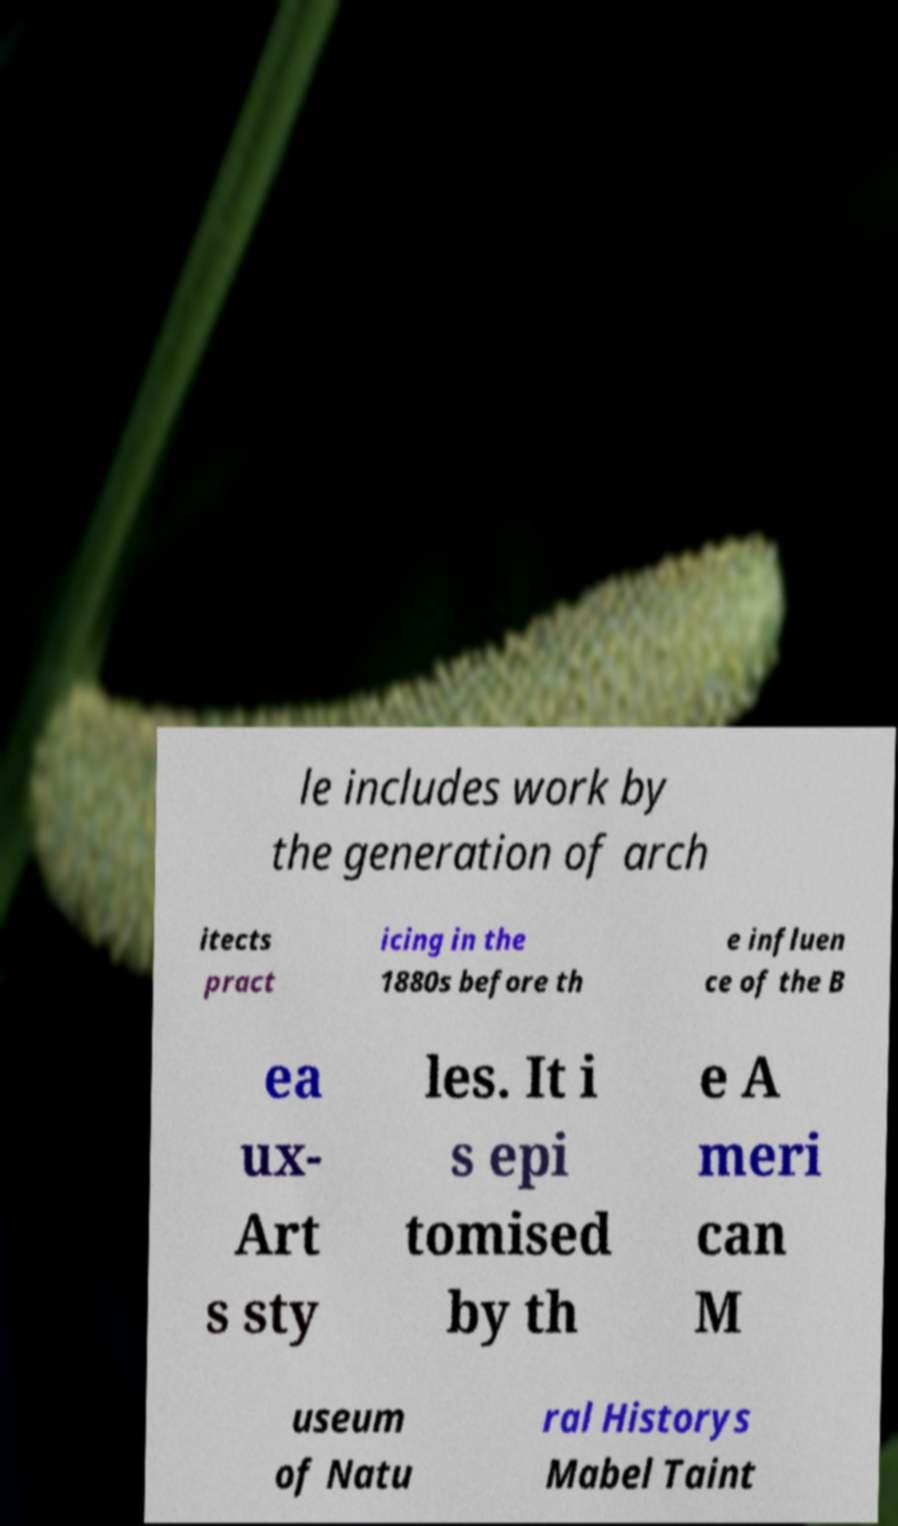There's text embedded in this image that I need extracted. Can you transcribe it verbatim? le includes work by the generation of arch itects pract icing in the 1880s before th e influen ce of the B ea ux- Art s sty les. It i s epi tomised by th e A meri can M useum of Natu ral Historys Mabel Taint 